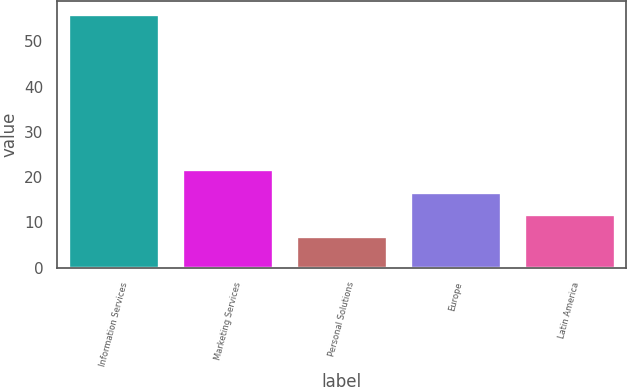Convert chart. <chart><loc_0><loc_0><loc_500><loc_500><bar_chart><fcel>Information Services<fcel>Marketing Services<fcel>Personal Solutions<fcel>Europe<fcel>Latin America<nl><fcel>56<fcel>21.7<fcel>7<fcel>16.8<fcel>11.9<nl></chart> 